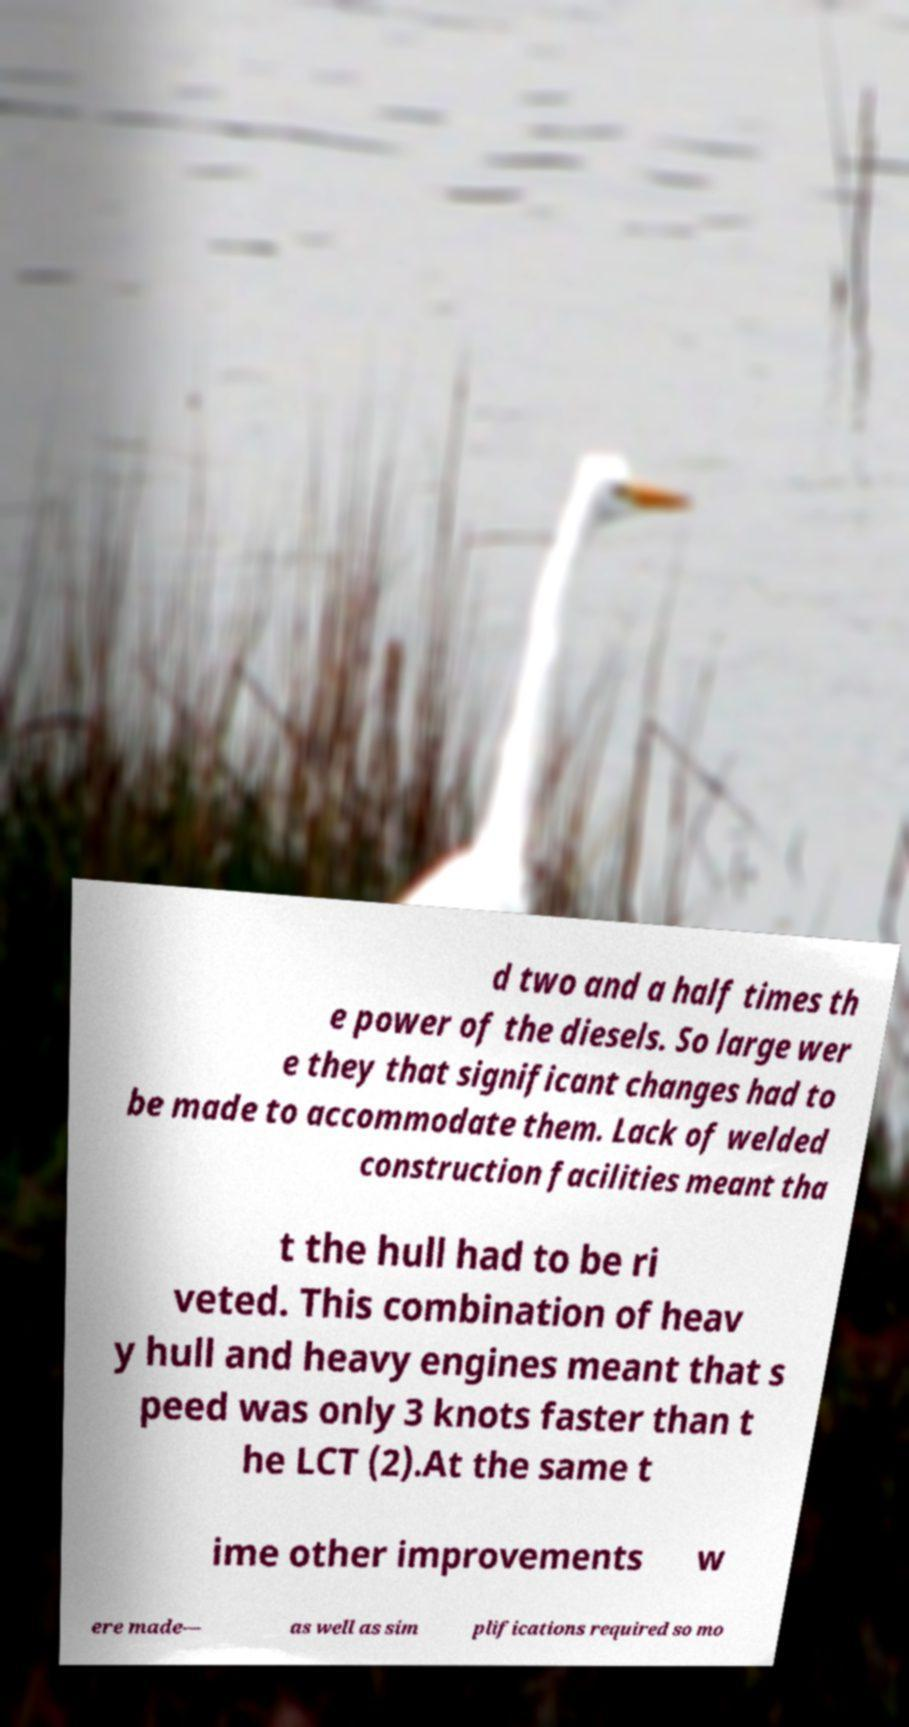Please identify and transcribe the text found in this image. d two and a half times th e power of the diesels. So large wer e they that significant changes had to be made to accommodate them. Lack of welded construction facilities meant tha t the hull had to be ri veted. This combination of heav y hull and heavy engines meant that s peed was only 3 knots faster than t he LCT (2).At the same t ime other improvements w ere made— as well as sim plifications required so mo 